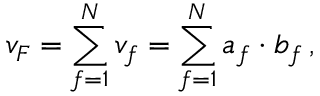Convert formula to latex. <formula><loc_0><loc_0><loc_500><loc_500>v _ { F } = \sum _ { f = 1 } ^ { N } v _ { f } = \sum _ { f = 1 } ^ { N } a _ { f } \cdot b _ { f } \, ,</formula> 